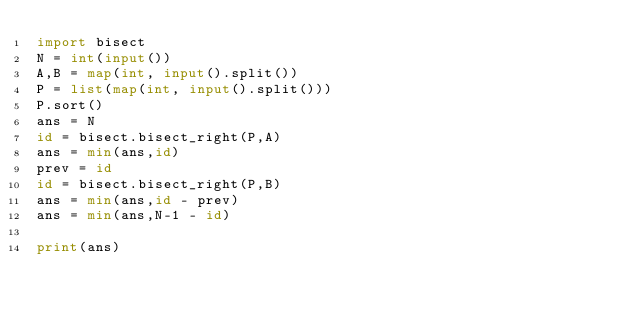Convert code to text. <code><loc_0><loc_0><loc_500><loc_500><_Python_>import bisect
N = int(input())
A,B = map(int, input().split())
P = list(map(int, input().split()))
P.sort()
ans = N
id = bisect.bisect_right(P,A)
ans = min(ans,id)
prev = id
id = bisect.bisect_right(P,B)
ans = min(ans,id - prev)
ans = min(ans,N-1 - id)

print(ans)</code> 